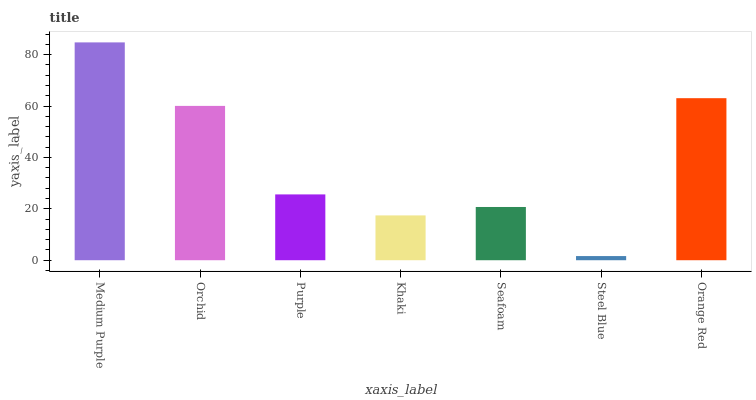Is Steel Blue the minimum?
Answer yes or no. Yes. Is Medium Purple the maximum?
Answer yes or no. Yes. Is Orchid the minimum?
Answer yes or no. No. Is Orchid the maximum?
Answer yes or no. No. Is Medium Purple greater than Orchid?
Answer yes or no. Yes. Is Orchid less than Medium Purple?
Answer yes or no. Yes. Is Orchid greater than Medium Purple?
Answer yes or no. No. Is Medium Purple less than Orchid?
Answer yes or no. No. Is Purple the high median?
Answer yes or no. Yes. Is Purple the low median?
Answer yes or no. Yes. Is Steel Blue the high median?
Answer yes or no. No. Is Orange Red the low median?
Answer yes or no. No. 